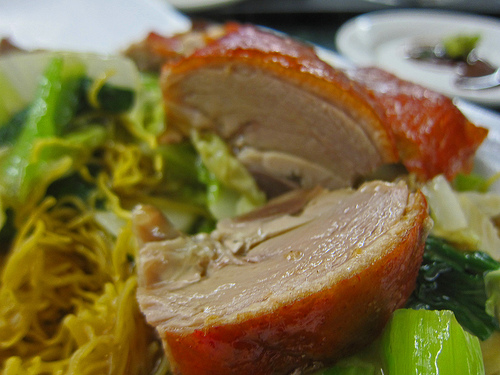<image>
Can you confirm if the pork is above the veggie? Yes. The pork is positioned above the veggie in the vertical space, higher up in the scene. 